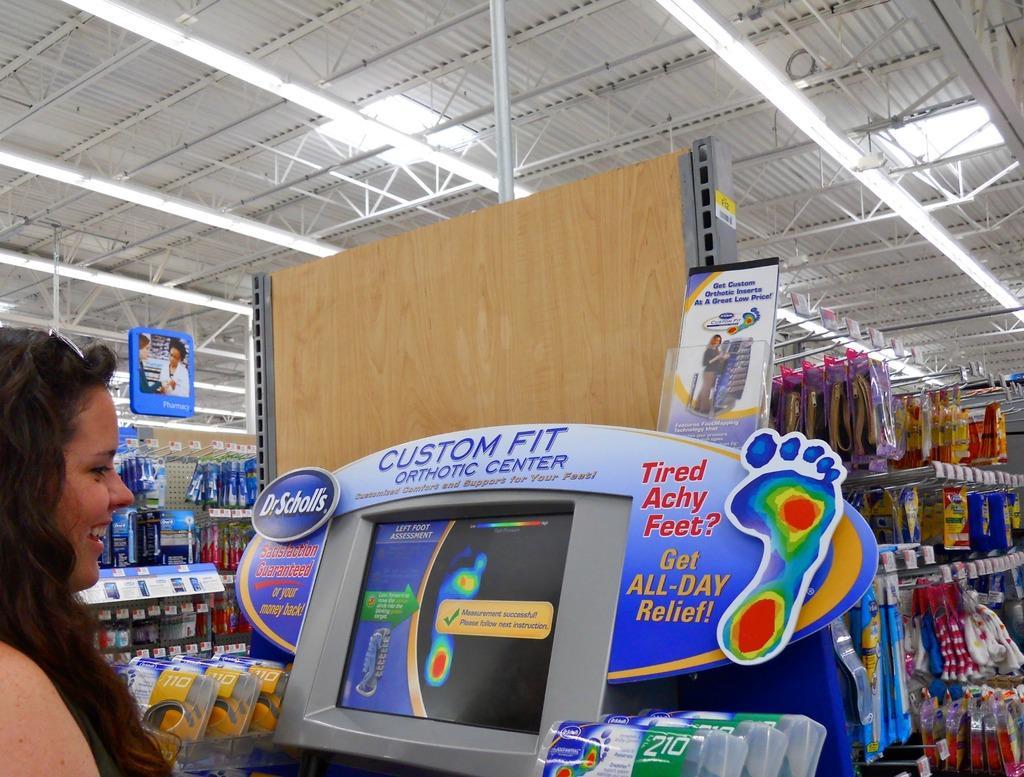Could you give a brief overview of what you see in this image? In the bottom left corner of the image a woman is standing and smiling. In front of her we can see a screen. Behind the screen we can see some racks, in the racks we can see some products. At the top of the image we can see roof, lights and banners. 